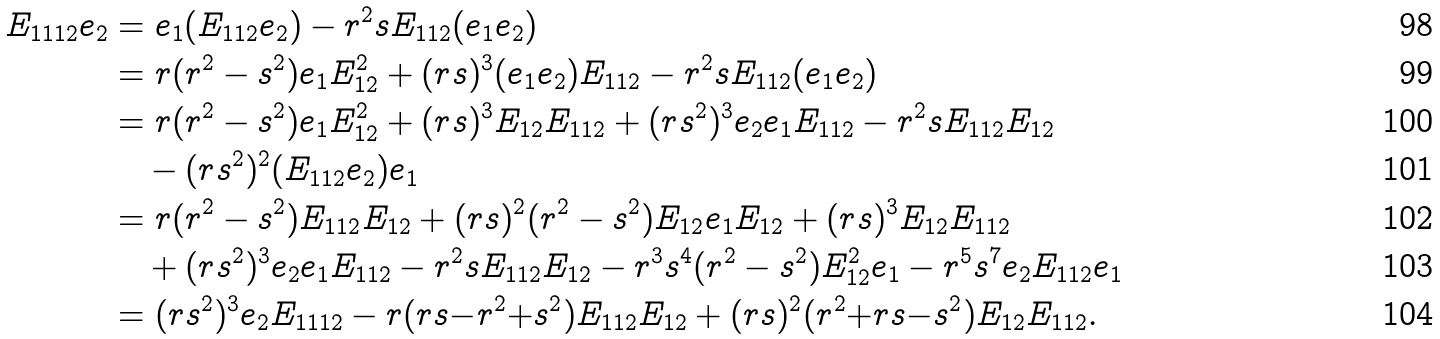Convert formula to latex. <formula><loc_0><loc_0><loc_500><loc_500>E _ { 1 1 1 2 } e _ { 2 } & = e _ { 1 } ( E _ { 1 1 2 } e _ { 2 } ) - r ^ { 2 } s E _ { 1 1 2 } ( e _ { 1 } e _ { 2 } ) \\ & = r ( r ^ { 2 } - s ^ { 2 } ) e _ { 1 } E _ { 1 2 } ^ { 2 } + ( r s ) ^ { 3 } ( e _ { 1 } e _ { 2 } ) E _ { 1 1 2 } - r ^ { 2 } s E _ { 1 1 2 } ( e _ { 1 } e _ { 2 } ) \\ & = r ( r ^ { 2 } - s ^ { 2 } ) e _ { 1 } E _ { 1 2 } ^ { 2 } + ( r s ) ^ { 3 } E _ { 1 2 } E _ { 1 1 2 } + ( r s ^ { 2 } ) ^ { 3 } e _ { 2 } e _ { 1 } E _ { 1 1 2 } - r ^ { 2 } s E _ { 1 1 2 } E _ { 1 2 } \\ & \quad - ( r s ^ { 2 } ) ^ { 2 } ( E _ { 1 1 2 } e _ { 2 } ) e _ { 1 } \\ & = r ( r ^ { 2 } - s ^ { 2 } ) E _ { 1 1 2 } E _ { 1 2 } + ( r s ) ^ { 2 } ( r ^ { 2 } - s ^ { 2 } ) E _ { 1 2 } e _ { 1 } E _ { 1 2 } + ( r s ) ^ { 3 } E _ { 1 2 } E _ { 1 1 2 } \\ & \quad + ( r s ^ { 2 } ) ^ { 3 } e _ { 2 } e _ { 1 } E _ { 1 1 2 } - r ^ { 2 } s E _ { 1 1 2 } E _ { 1 2 } - r ^ { 3 } s ^ { 4 } ( r ^ { 2 } - s ^ { 2 } ) E _ { 1 2 } ^ { 2 } e _ { 1 } - r ^ { 5 } s ^ { 7 } e _ { 2 } E _ { 1 1 2 } e _ { 1 } \\ & = ( r s ^ { 2 } ) ^ { 3 } e _ { 2 } E _ { 1 1 1 2 } - r ( r s { - } r ^ { 2 } { + } s ^ { 2 } ) E _ { 1 1 2 } E _ { 1 2 } + ( r s ) ^ { 2 } ( r ^ { 2 } { + } r s { - } s ^ { 2 } ) E _ { 1 2 } E _ { 1 1 2 } .</formula> 